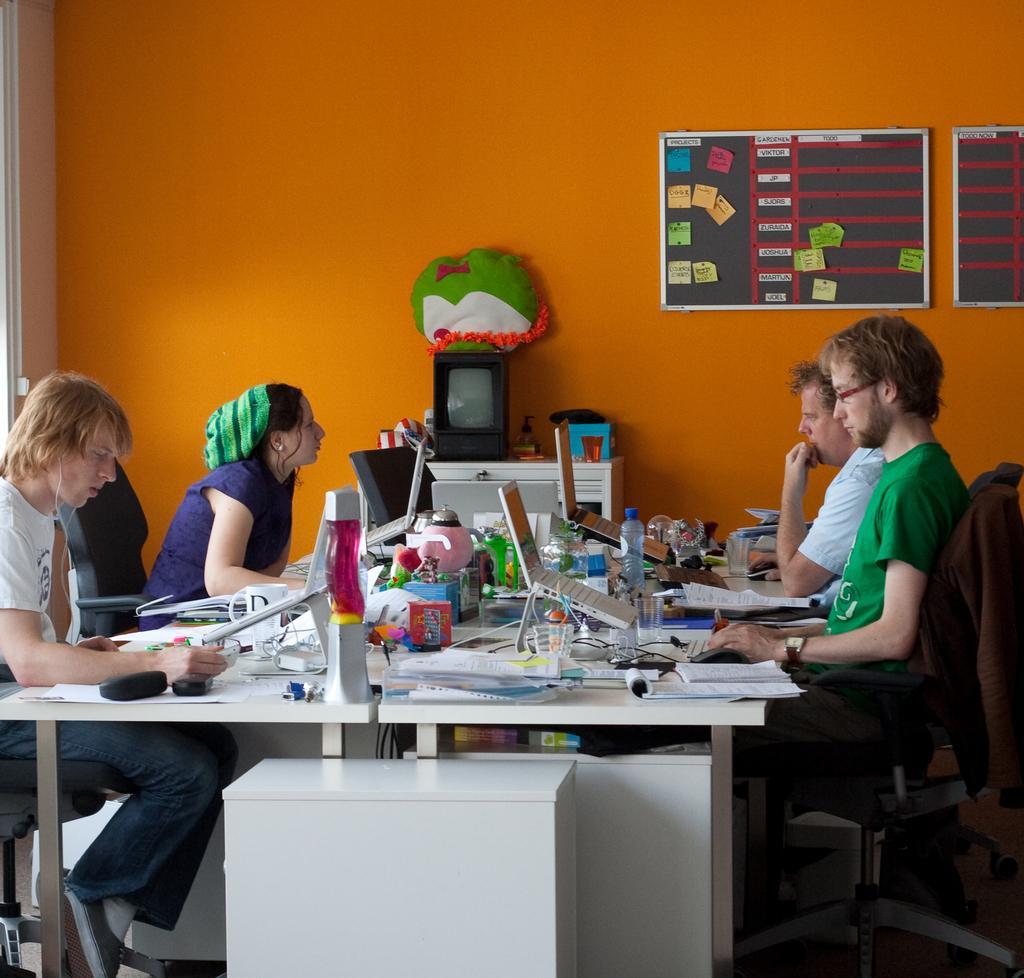Can you describe this image briefly? In this image we can see there are four people sit on their chairs. In between them there is a table. On the table there monitors, keyboard, mouse, bottle, glass and some other objects placed on it, back of this table there is another table and there is stuff on it. In the background there is a wall and some boards hanging to it. 